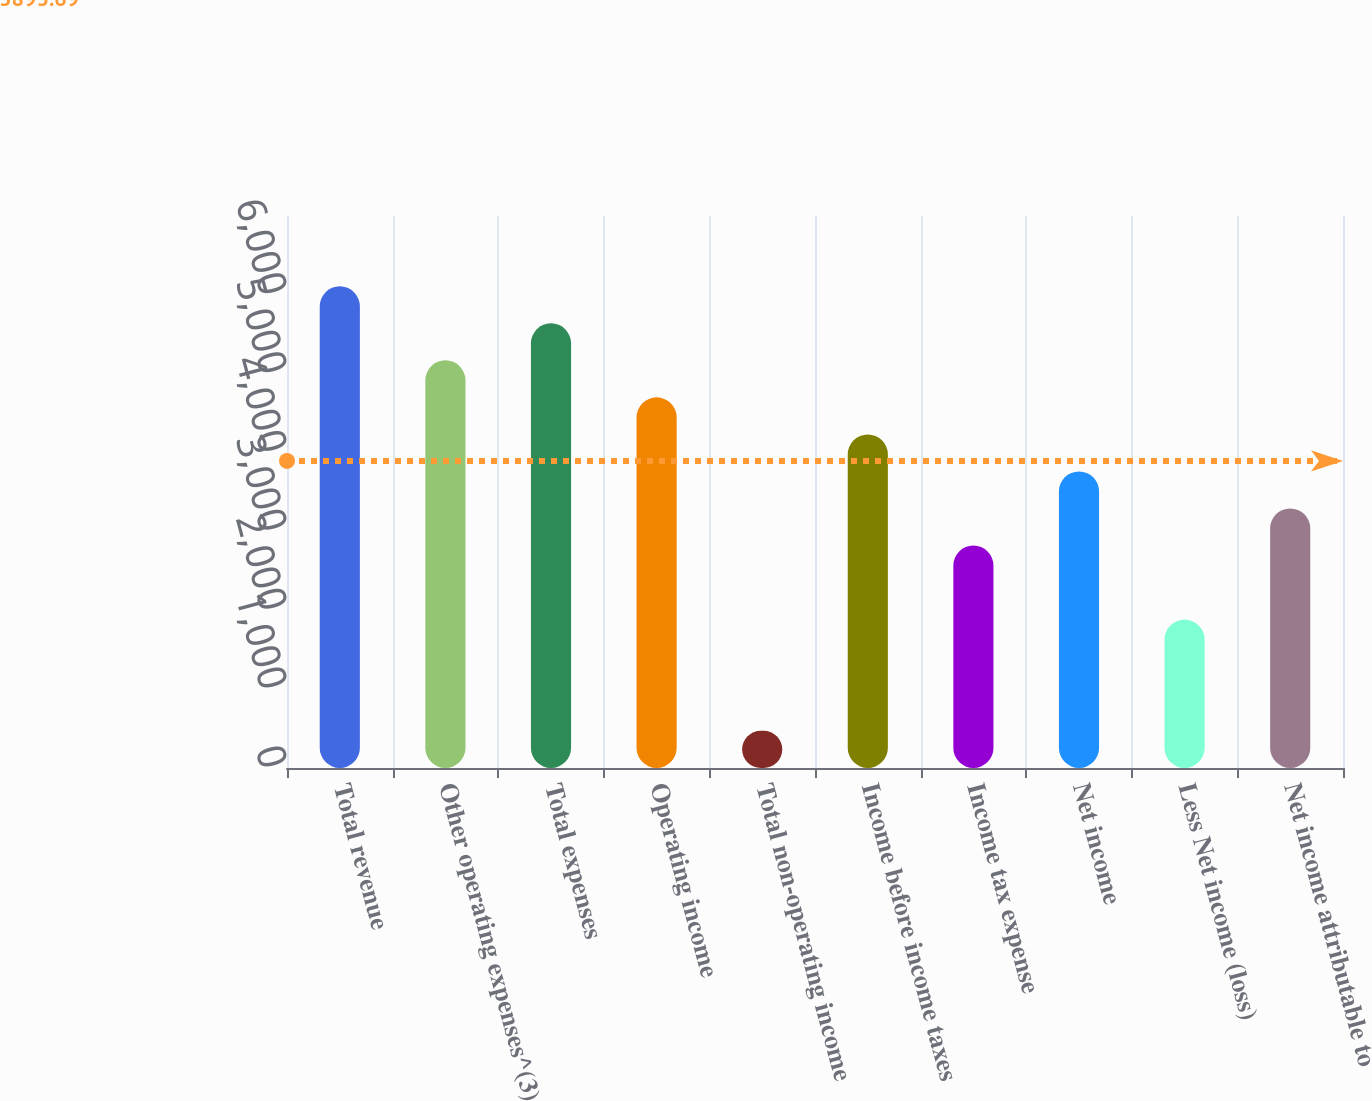<chart> <loc_0><loc_0><loc_500><loc_500><bar_chart><fcel>Total revenue<fcel>Other operating expenses^(3)<fcel>Total expenses<fcel>Operating income<fcel>Total non-operating income<fcel>Income before income taxes<fcel>Income tax expense<fcel>Net income<fcel>Less Net income (loss)<fcel>Net income attributable to<nl><fcel>6109.09<fcel>5169.71<fcel>5639.4<fcel>4700.02<fcel>472.81<fcel>4230.33<fcel>2821.26<fcel>3760.64<fcel>1881.88<fcel>3290.95<nl></chart> 